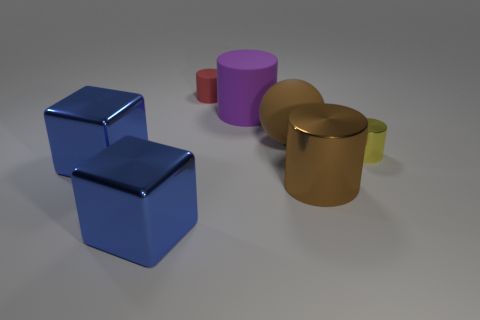Subtract all large matte cylinders. How many cylinders are left? 3 Add 3 purple cylinders. How many objects exist? 10 Subtract all yellow cylinders. How many cylinders are left? 3 Add 2 large rubber spheres. How many large rubber spheres exist? 3 Subtract 0 brown blocks. How many objects are left? 7 Subtract all cylinders. How many objects are left? 3 Subtract 1 cylinders. How many cylinders are left? 3 Subtract all brown cylinders. Subtract all green balls. How many cylinders are left? 3 Subtract all tiny blue cubes. Subtract all tiny rubber cylinders. How many objects are left? 6 Add 6 metallic cylinders. How many metallic cylinders are left? 8 